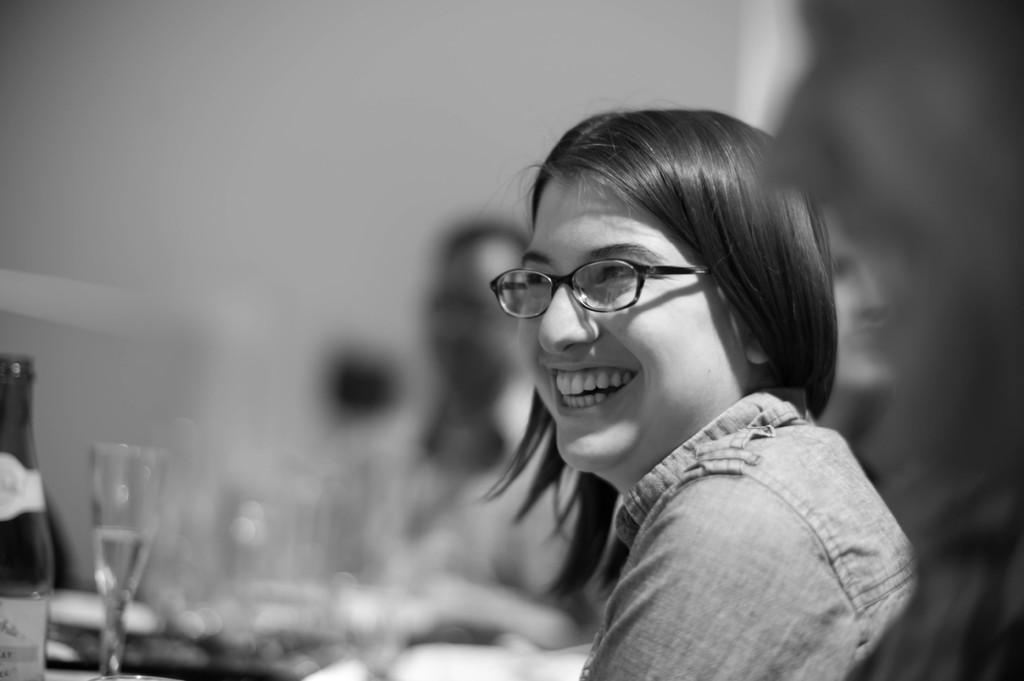Who is present in the image? There is a woman in the image. What is the woman doing in the image? The woman is smiling in the image. What is on the table in the image? There is a bottle of wine and glasses on the table in the image. Are there any other people visible in the image? Yes, there are other people visible behind the woman in the image. What type of wound can be seen on the woman's arm in the image? There is no wound visible on the woman's arm in the image. What type of soda is being served in the glasses on the table? The image does not show any soda; it shows a bottle of wine and glasses. 